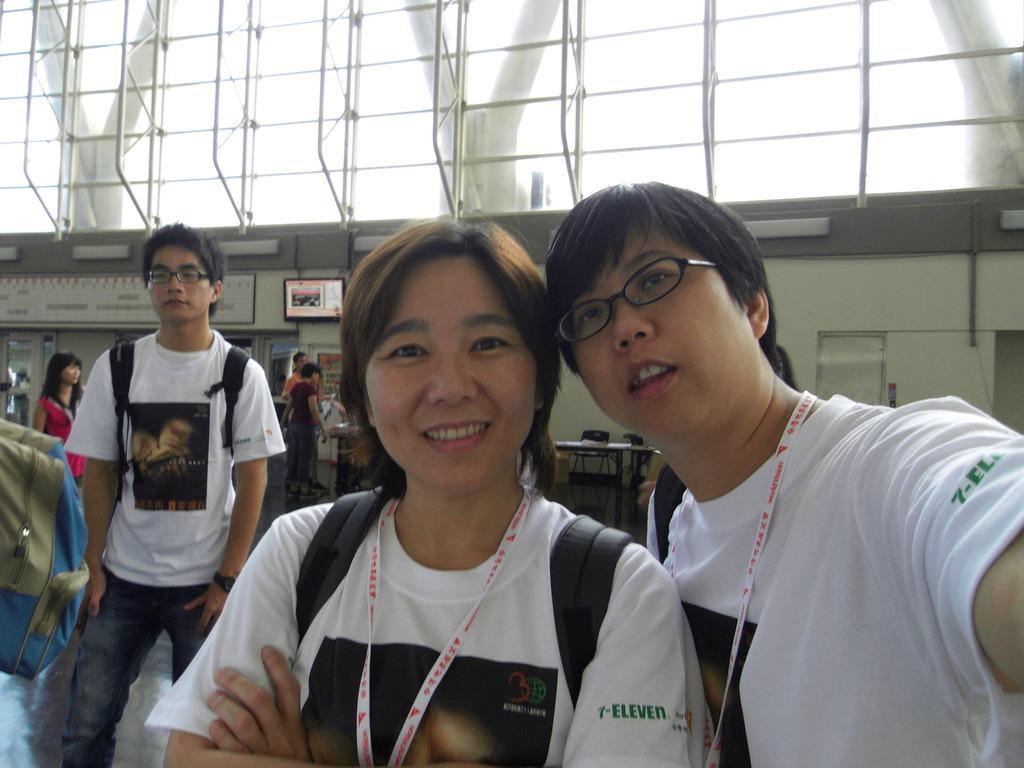In one or two sentences, can you explain what this image depicts? In this image I can see three persons wearing white and black t shirt and black colored bag are standing. I can see 2 of them are wearing spectacles. In the background I can see few persons standing, the white colored wall, the television screen and few windows. To the left side of the image I can see a bag. 